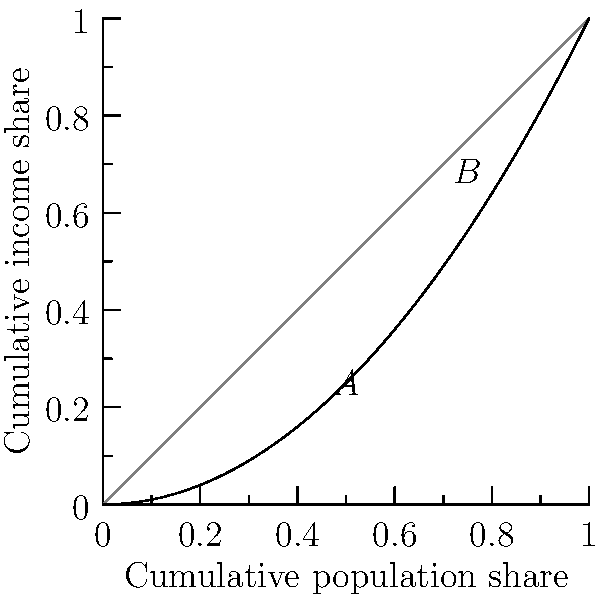The Lorenz curve for a Belt and Road country is given by the function $L(x) = x^2$, where $x$ represents the cumulative share of the population and $L(x)$ represents the cumulative share of income. Calculate the Gini coefficient for this country. Round your answer to three decimal places. To calculate the Gini coefficient using the Lorenz curve, we follow these steps:

1) The Gini coefficient is defined as $G = \frac{A}{A+B}$, where $A$ is the area between the line of perfect equality and the Lorenz curve, and $B$ is the area under the Lorenz curve.

2) The area of the triangle under the line of perfect equality is $\frac{1}{2}$.

3) To find $B$, we need to integrate the Lorenz curve function from 0 to 1:
   $B = \int_0^1 x^2 dx = [\frac{1}{3}x^3]_0^1 = \frac{1}{3}$

4) The area $A$ is the difference between the area of the triangle and $B$:
   $A = \frac{1}{2} - \frac{1}{3} = \frac{1}{6}$

5) Now we can calculate the Gini coefficient:
   $G = \frac{A}{A+B} = \frac{\frac{1}{6}}{\frac{1}{6}+\frac{1}{3}} = \frac{\frac{1}{6}}{\frac{1}{2}} = \frac{1}{3} \approx 0.333$

Therefore, the Gini coefficient rounded to three decimal places is 0.333.
Answer: 0.333 